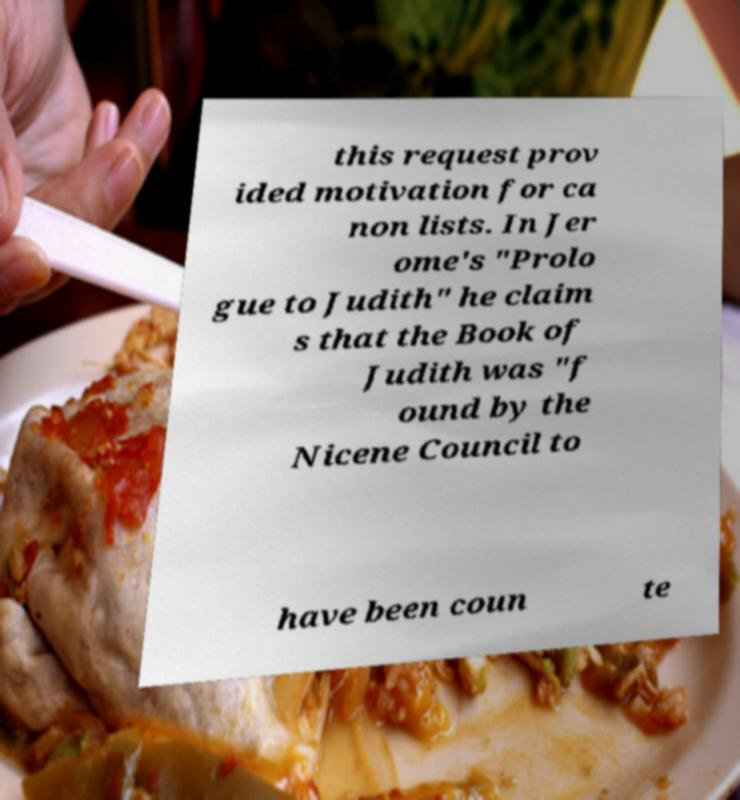Can you accurately transcribe the text from the provided image for me? this request prov ided motivation for ca non lists. In Jer ome's "Prolo gue to Judith" he claim s that the Book of Judith was "f ound by the Nicene Council to have been coun te 